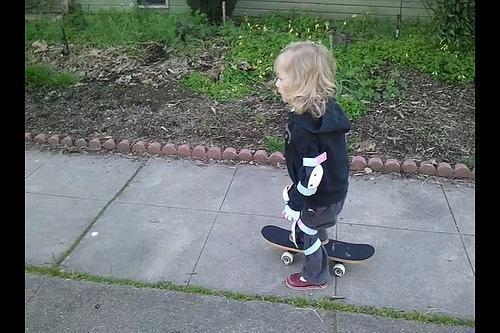How many skateboards do you see?
Give a very brief answer. 1. 